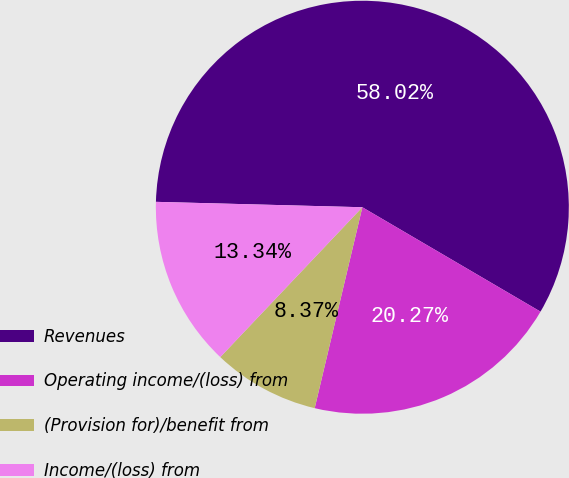<chart> <loc_0><loc_0><loc_500><loc_500><pie_chart><fcel>Revenues<fcel>Operating income/(loss) from<fcel>(Provision for)/benefit from<fcel>Income/(loss) from<nl><fcel>58.02%<fcel>20.27%<fcel>8.37%<fcel>13.34%<nl></chart> 